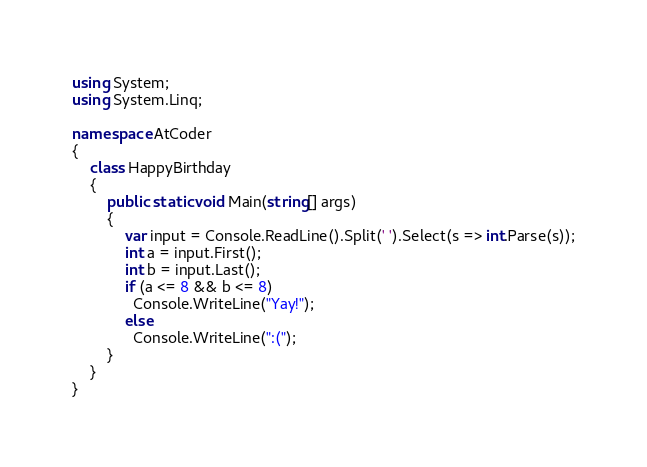Convert code to text. <code><loc_0><loc_0><loc_500><loc_500><_C#_>using System;
using System.Linq;
 
namespace AtCoder
{
    class HappyBirthday
    {
        public static void Main(string[] args)
        {
            var input = Console.ReadLine().Split(' ').Select(s => int.Parse(s));
            int a = input.First();
	        int b = input.Last();
            if (a <= 8 && b <= 8)
              Console.WriteLine("Yay!");
          	else
              Console.WriteLine(":(");
        }
    }
}</code> 